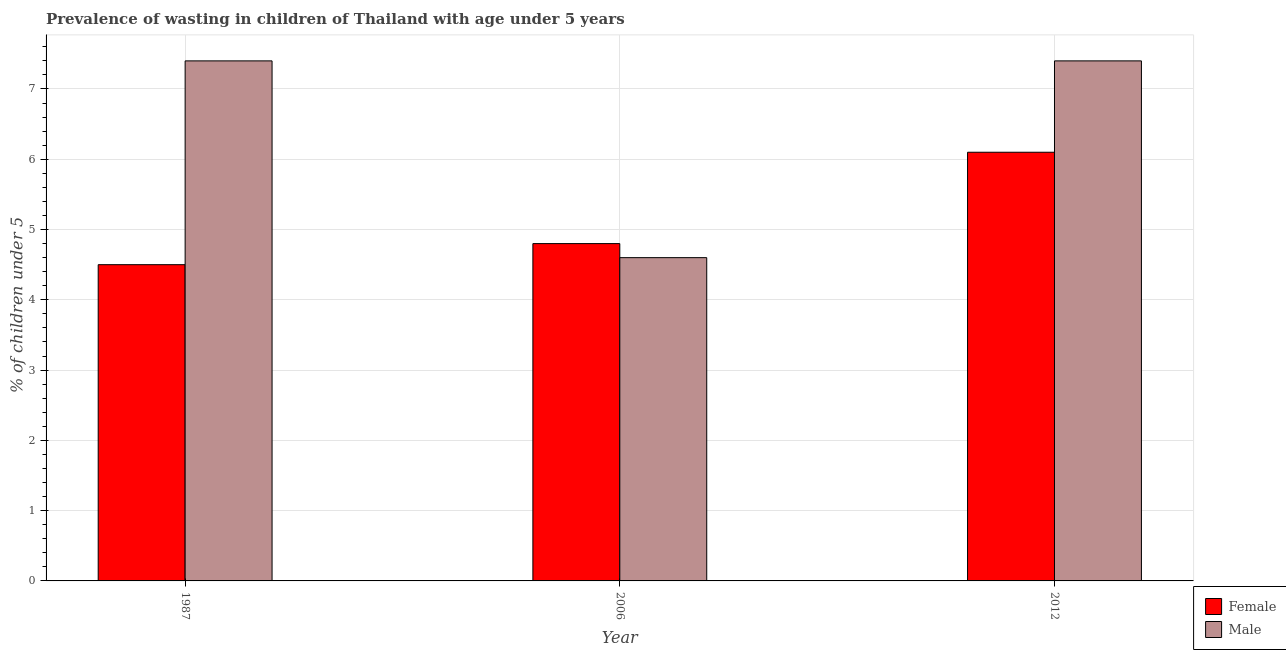How many different coloured bars are there?
Provide a short and direct response. 2. How many groups of bars are there?
Offer a very short reply. 3. Are the number of bars per tick equal to the number of legend labels?
Keep it short and to the point. Yes. Are the number of bars on each tick of the X-axis equal?
Give a very brief answer. Yes. How many bars are there on the 3rd tick from the left?
Ensure brevity in your answer.  2. How many bars are there on the 1st tick from the right?
Your answer should be compact. 2. In how many cases, is the number of bars for a given year not equal to the number of legend labels?
Keep it short and to the point. 0. What is the percentage of undernourished male children in 1987?
Make the answer very short. 7.4. Across all years, what is the maximum percentage of undernourished female children?
Offer a terse response. 6.1. Across all years, what is the minimum percentage of undernourished female children?
Offer a very short reply. 4.5. What is the total percentage of undernourished male children in the graph?
Provide a succinct answer. 19.4. What is the difference between the percentage of undernourished male children in 2006 and that in 2012?
Offer a very short reply. -2.8. What is the difference between the percentage of undernourished female children in 2012 and the percentage of undernourished male children in 1987?
Ensure brevity in your answer.  1.6. What is the average percentage of undernourished male children per year?
Your response must be concise. 6.47. Is the difference between the percentage of undernourished male children in 1987 and 2012 greater than the difference between the percentage of undernourished female children in 1987 and 2012?
Your response must be concise. No. What is the difference between the highest and the second highest percentage of undernourished male children?
Ensure brevity in your answer.  0. What is the difference between the highest and the lowest percentage of undernourished male children?
Give a very brief answer. 2.8. What does the 2nd bar from the right in 2006 represents?
Your response must be concise. Female. How many bars are there?
Make the answer very short. 6. Are all the bars in the graph horizontal?
Your response must be concise. No. How many years are there in the graph?
Make the answer very short. 3. Does the graph contain any zero values?
Your response must be concise. No. How many legend labels are there?
Keep it short and to the point. 2. What is the title of the graph?
Offer a very short reply. Prevalence of wasting in children of Thailand with age under 5 years. Does "UN agencies" appear as one of the legend labels in the graph?
Give a very brief answer. No. What is the label or title of the X-axis?
Make the answer very short. Year. What is the label or title of the Y-axis?
Your answer should be compact.  % of children under 5. What is the  % of children under 5 in Male in 1987?
Ensure brevity in your answer.  7.4. What is the  % of children under 5 of Female in 2006?
Give a very brief answer. 4.8. What is the  % of children under 5 of Male in 2006?
Keep it short and to the point. 4.6. What is the  % of children under 5 of Female in 2012?
Ensure brevity in your answer.  6.1. What is the  % of children under 5 of Male in 2012?
Your response must be concise. 7.4. Across all years, what is the maximum  % of children under 5 of Female?
Your answer should be very brief. 6.1. Across all years, what is the maximum  % of children under 5 of Male?
Your response must be concise. 7.4. Across all years, what is the minimum  % of children under 5 of Female?
Offer a very short reply. 4.5. Across all years, what is the minimum  % of children under 5 of Male?
Offer a very short reply. 4.6. What is the total  % of children under 5 in Male in the graph?
Provide a succinct answer. 19.4. What is the difference between the  % of children under 5 in Female in 1987 and that in 2006?
Offer a very short reply. -0.3. What is the difference between the  % of children under 5 of Female in 1987 and that in 2012?
Your response must be concise. -1.6. What is the difference between the  % of children under 5 of Male in 1987 and that in 2012?
Give a very brief answer. 0. What is the difference between the  % of children under 5 in Male in 2006 and that in 2012?
Provide a succinct answer. -2.8. What is the difference between the  % of children under 5 in Female in 1987 and the  % of children under 5 in Male in 2006?
Your response must be concise. -0.1. What is the difference between the  % of children under 5 of Female in 2006 and the  % of children under 5 of Male in 2012?
Provide a short and direct response. -2.6. What is the average  % of children under 5 of Female per year?
Offer a very short reply. 5.13. What is the average  % of children under 5 of Male per year?
Keep it short and to the point. 6.47. In the year 2006, what is the difference between the  % of children under 5 of Female and  % of children under 5 of Male?
Provide a succinct answer. 0.2. In the year 2012, what is the difference between the  % of children under 5 in Female and  % of children under 5 in Male?
Provide a short and direct response. -1.3. What is the ratio of the  % of children under 5 of Female in 1987 to that in 2006?
Provide a short and direct response. 0.94. What is the ratio of the  % of children under 5 in Male in 1987 to that in 2006?
Provide a succinct answer. 1.61. What is the ratio of the  % of children under 5 of Female in 1987 to that in 2012?
Give a very brief answer. 0.74. What is the ratio of the  % of children under 5 in Female in 2006 to that in 2012?
Your answer should be compact. 0.79. What is the ratio of the  % of children under 5 of Male in 2006 to that in 2012?
Your response must be concise. 0.62. What is the difference between the highest and the lowest  % of children under 5 in Female?
Your response must be concise. 1.6. What is the difference between the highest and the lowest  % of children under 5 of Male?
Offer a very short reply. 2.8. 